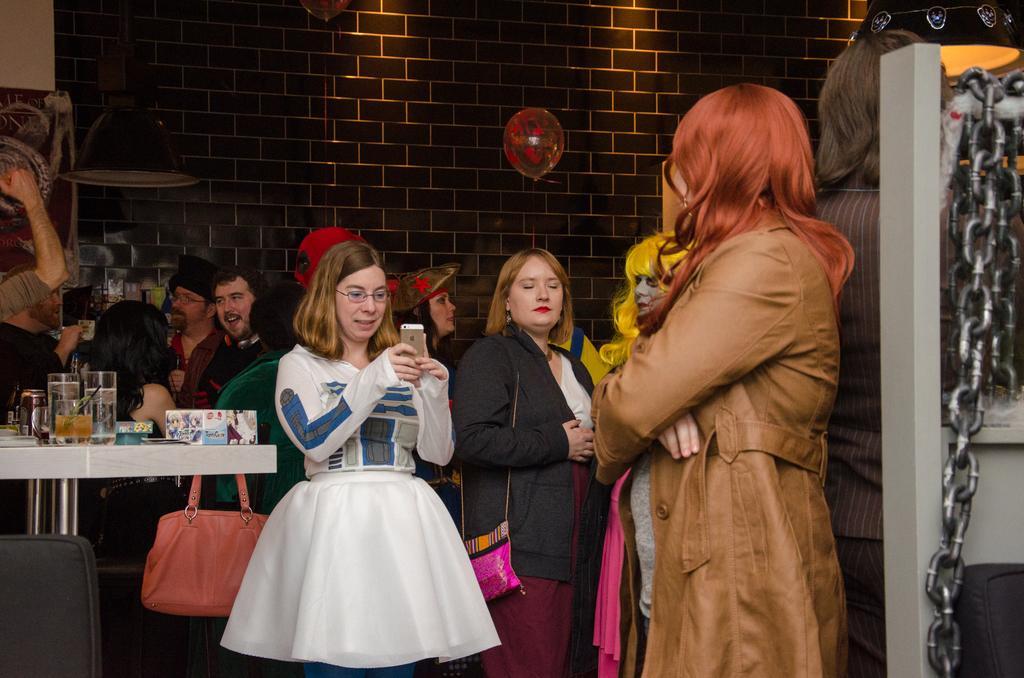Please provide a concise description of this image. The picture is taken inside a building. There are many people. In the foreground a lady wearing white dress is holding a phone. Here on a table there are glasses, packets and few other things are there. Here there is metal chain. Here there is a balloon. In the background there is wall. 